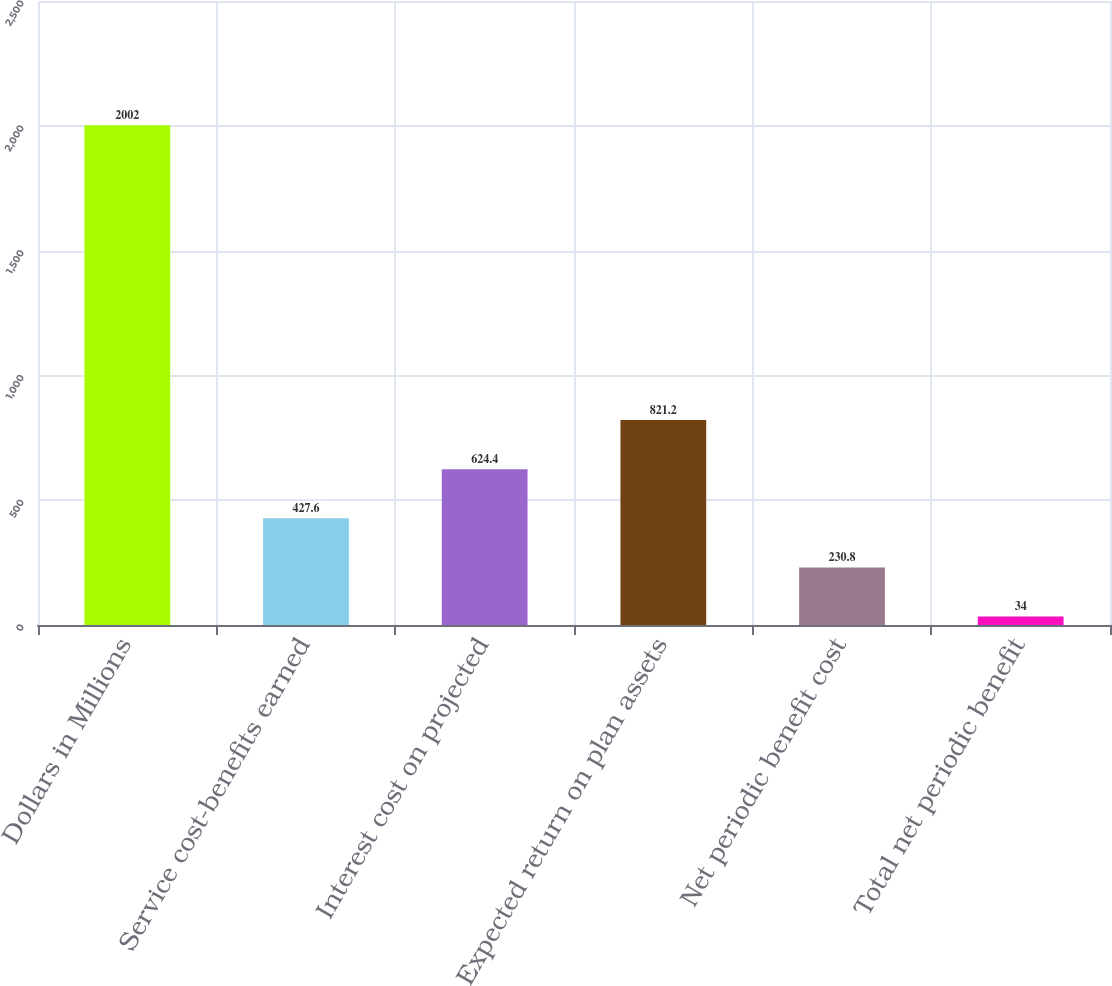Convert chart to OTSL. <chart><loc_0><loc_0><loc_500><loc_500><bar_chart><fcel>Dollars in Millions<fcel>Service cost-benefits earned<fcel>Interest cost on projected<fcel>Expected return on plan assets<fcel>Net periodic benefit cost<fcel>Total net periodic benefit<nl><fcel>2002<fcel>427.6<fcel>624.4<fcel>821.2<fcel>230.8<fcel>34<nl></chart> 